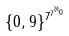Convert formula to latex. <formula><loc_0><loc_0><loc_500><loc_500>\{ 0 , 9 \} ^ { 7 ^ { 7 ^ { \aleph _ { 0 } } } }</formula> 